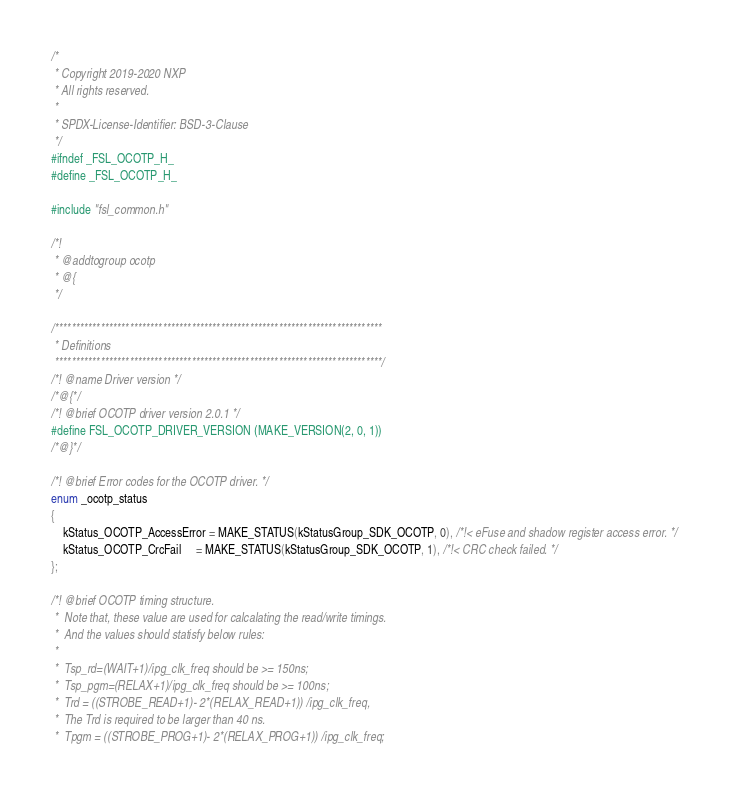Convert code to text. <code><loc_0><loc_0><loc_500><loc_500><_C_>/*
 * Copyright 2019-2020 NXP
 * All rights reserved.
 *
 * SPDX-License-Identifier: BSD-3-Clause
 */
#ifndef _FSL_OCOTP_H_
#define _FSL_OCOTP_H_

#include "fsl_common.h"

/*!
 * @addtogroup ocotp
 * @{
 */

/*******************************************************************************
 * Definitions
 *******************************************************************************/
/*! @name Driver version */
/*@{*/
/*! @brief OCOTP driver version 2.0.1 */
#define FSL_OCOTP_DRIVER_VERSION (MAKE_VERSION(2, 0, 1))
/*@}*/

/*! @brief Error codes for the OCOTP driver. */
enum _ocotp_status
{
    kStatus_OCOTP_AccessError = MAKE_STATUS(kStatusGroup_SDK_OCOTP, 0), /*!< eFuse and shadow register access error. */
    kStatus_OCOTP_CrcFail     = MAKE_STATUS(kStatusGroup_SDK_OCOTP, 1), /*!< CRC check failed. */
};

/*! @brief OCOTP timing structure.
 *  Note that, these value are used for calcalating the read/write timings.
 *  And the values should statisfy below rules:
 *
 *  Tsp_rd=(WAIT+1)/ipg_clk_freq should be >= 150ns;
 *  Tsp_pgm=(RELAX+1)/ipg_clk_freq should be >= 100ns;
 *  Trd = ((STROBE_READ+1)- 2*(RELAX_READ+1)) /ipg_clk_freq,
 *  The Trd is required to be larger than 40 ns.
 *  Tpgm = ((STROBE_PROG+1)- 2*(RELAX_PROG+1)) /ipg_clk_freq;</code> 